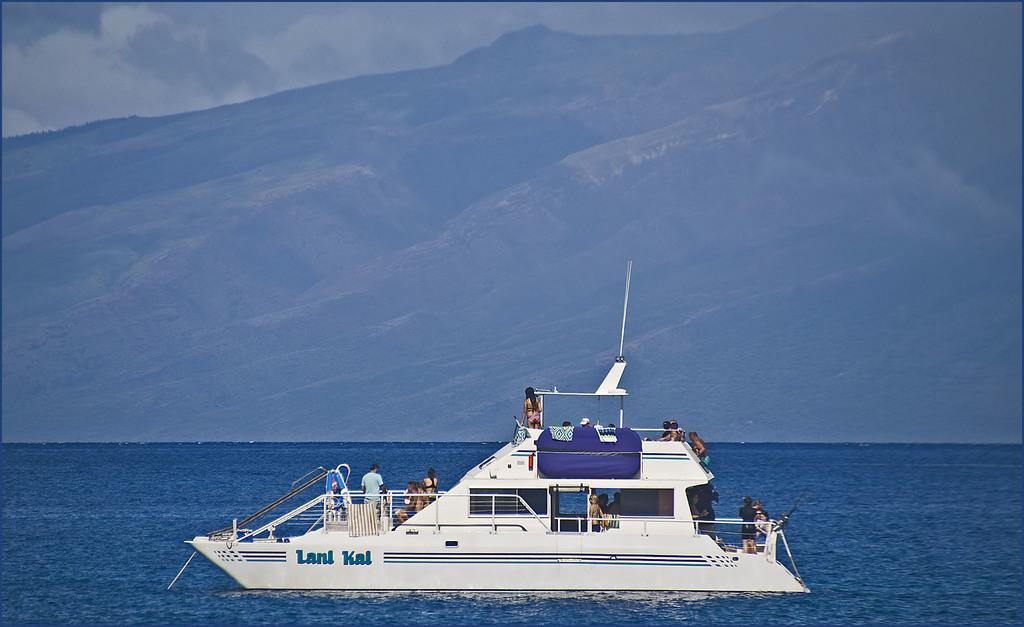What is the main subject of the image? The main subject of the image is a boat. What is the boat doing in the image? The boat is floating on water in the image. Where is the boat located in the image? The boat is in the bottom of the image. Who is in the boat? There are people in the boat. What can be seen in the background of the image? Hills are visible in the background of the image. How does the boat wash the snail in the image? There is no snail present in the image, and the boat is not washing anything. 